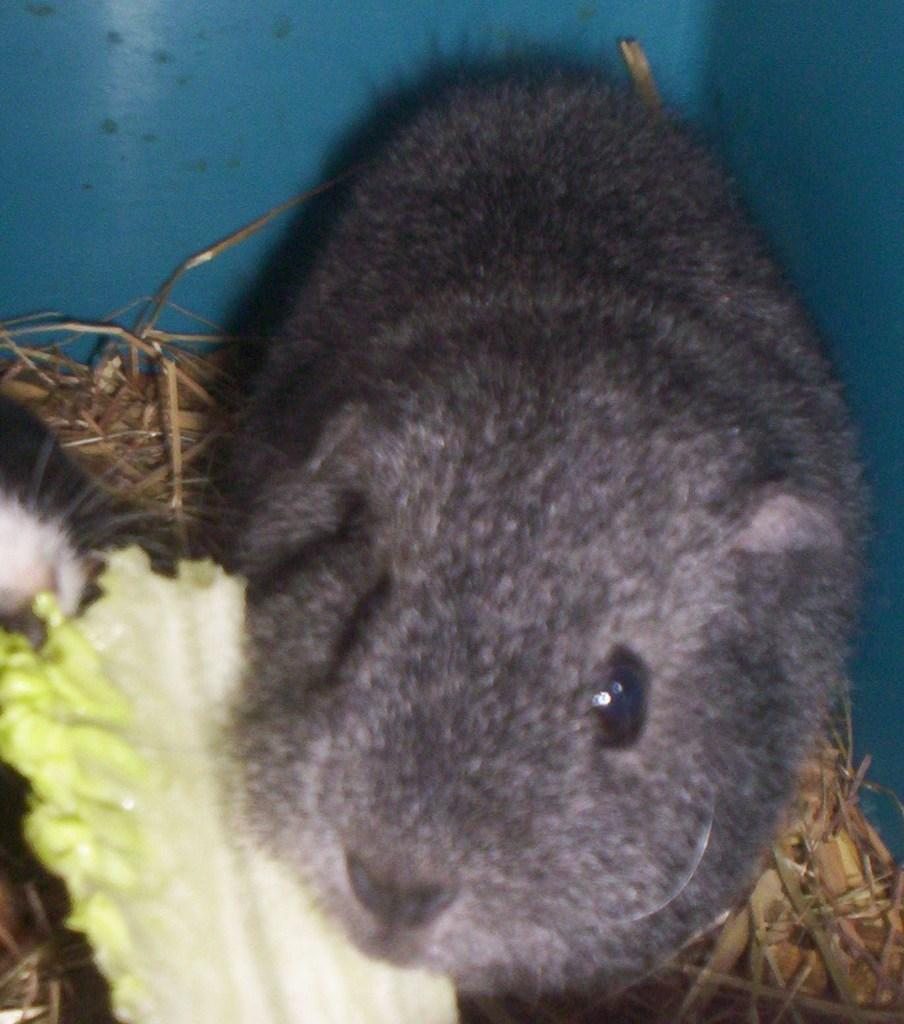What animal is present in the image? There is a guinea pig in the image. Where is the guinea pig located? The guinea pig is in a box. What type of vegetation is visible in the image? There is grass in the image. What food item is present in the image? There is a cabbage leaf in the image. What type of bone is visible in the image? There is no bone present in the image. How does the turkey interact with the guinea pig in the image? There is no turkey present in the image, so it cannot interact with the guinea pig. 